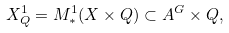<formula> <loc_0><loc_0><loc_500><loc_500>X ^ { 1 } _ { Q } = M ^ { 1 } _ { * } ( X \times Q ) \subset A ^ { G } \times Q ,</formula> 